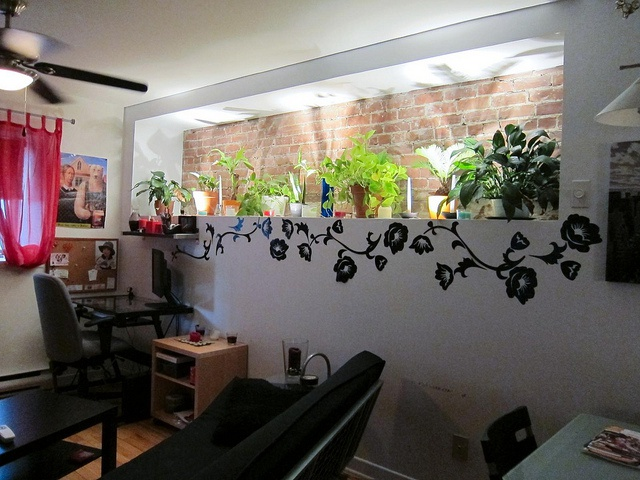Describe the objects in this image and their specific colors. I can see couch in black and gray tones, potted plant in black, gray, darkgray, and beige tones, dining table in black, navy, blue, and darkblue tones, dining table in black and gray tones, and chair in black and gray tones in this image. 